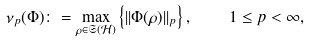<formula> <loc_0><loc_0><loc_500><loc_500>\nu _ { p } ( \Phi ) \colon = \max _ { \rho \in \mathfrak { S } ( \mathcal { H } ) } \left \{ | | \Phi ( \rho ) | | _ { p } \right \} , \quad 1 \leq p < \infty ,</formula> 